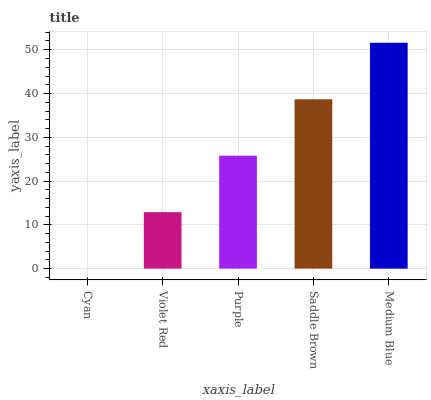Is Cyan the minimum?
Answer yes or no. Yes. Is Medium Blue the maximum?
Answer yes or no. Yes. Is Violet Red the minimum?
Answer yes or no. No. Is Violet Red the maximum?
Answer yes or no. No. Is Violet Red greater than Cyan?
Answer yes or no. Yes. Is Cyan less than Violet Red?
Answer yes or no. Yes. Is Cyan greater than Violet Red?
Answer yes or no. No. Is Violet Red less than Cyan?
Answer yes or no. No. Is Purple the high median?
Answer yes or no. Yes. Is Purple the low median?
Answer yes or no. Yes. Is Medium Blue the high median?
Answer yes or no. No. Is Violet Red the low median?
Answer yes or no. No. 